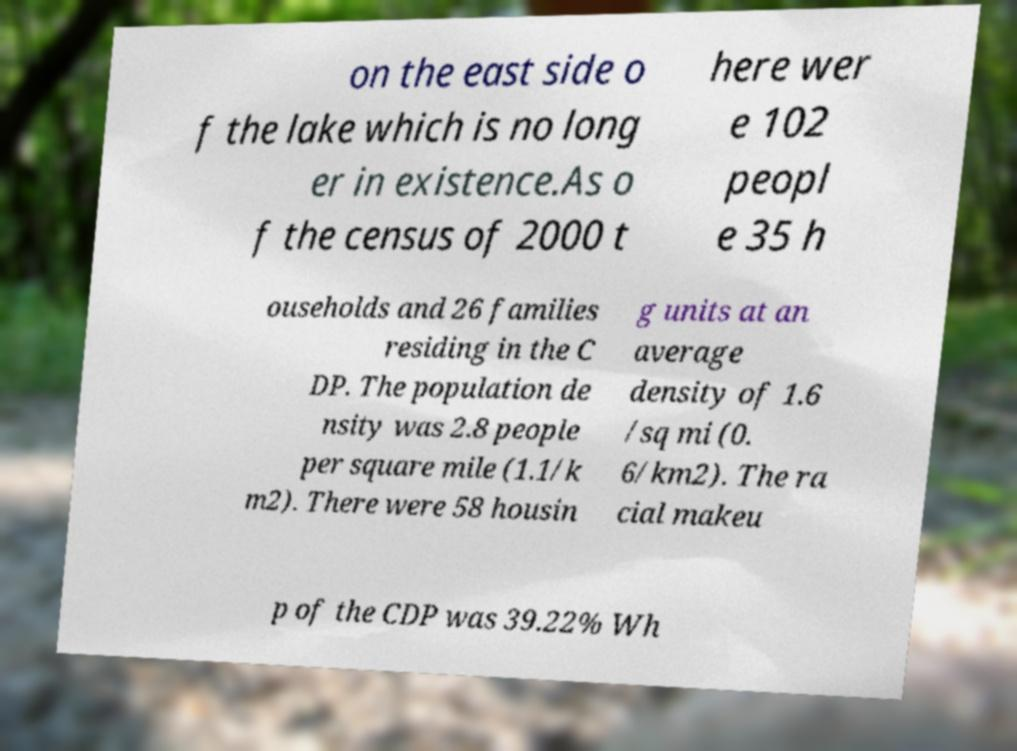There's text embedded in this image that I need extracted. Can you transcribe it verbatim? on the east side o f the lake which is no long er in existence.As o f the census of 2000 t here wer e 102 peopl e 35 h ouseholds and 26 families residing in the C DP. The population de nsity was 2.8 people per square mile (1.1/k m2). There were 58 housin g units at an average density of 1.6 /sq mi (0. 6/km2). The ra cial makeu p of the CDP was 39.22% Wh 